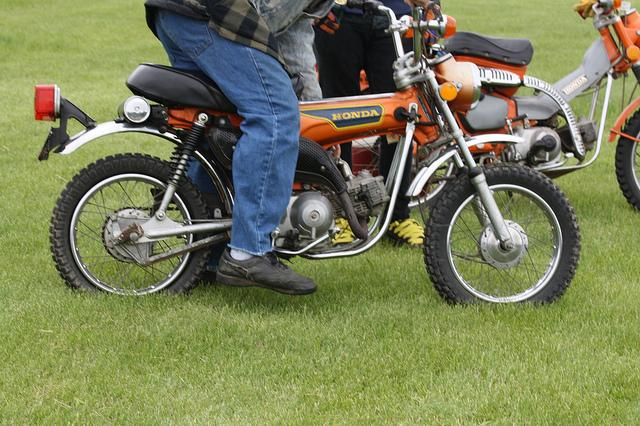What type of road are the small motorcycles created for? Please explain your reasoning. trails. The bikes are used for roads and trails. 